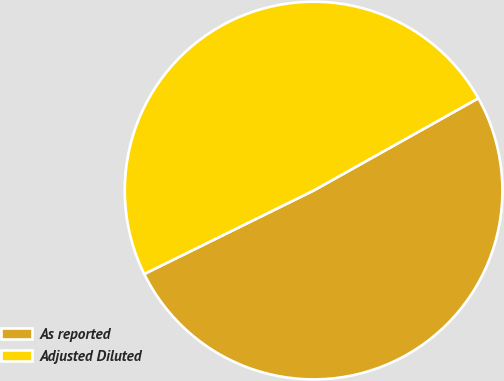Convert chart. <chart><loc_0><loc_0><loc_500><loc_500><pie_chart><fcel>As reported<fcel>Adjusted Diluted<nl><fcel>50.84%<fcel>49.16%<nl></chart> 